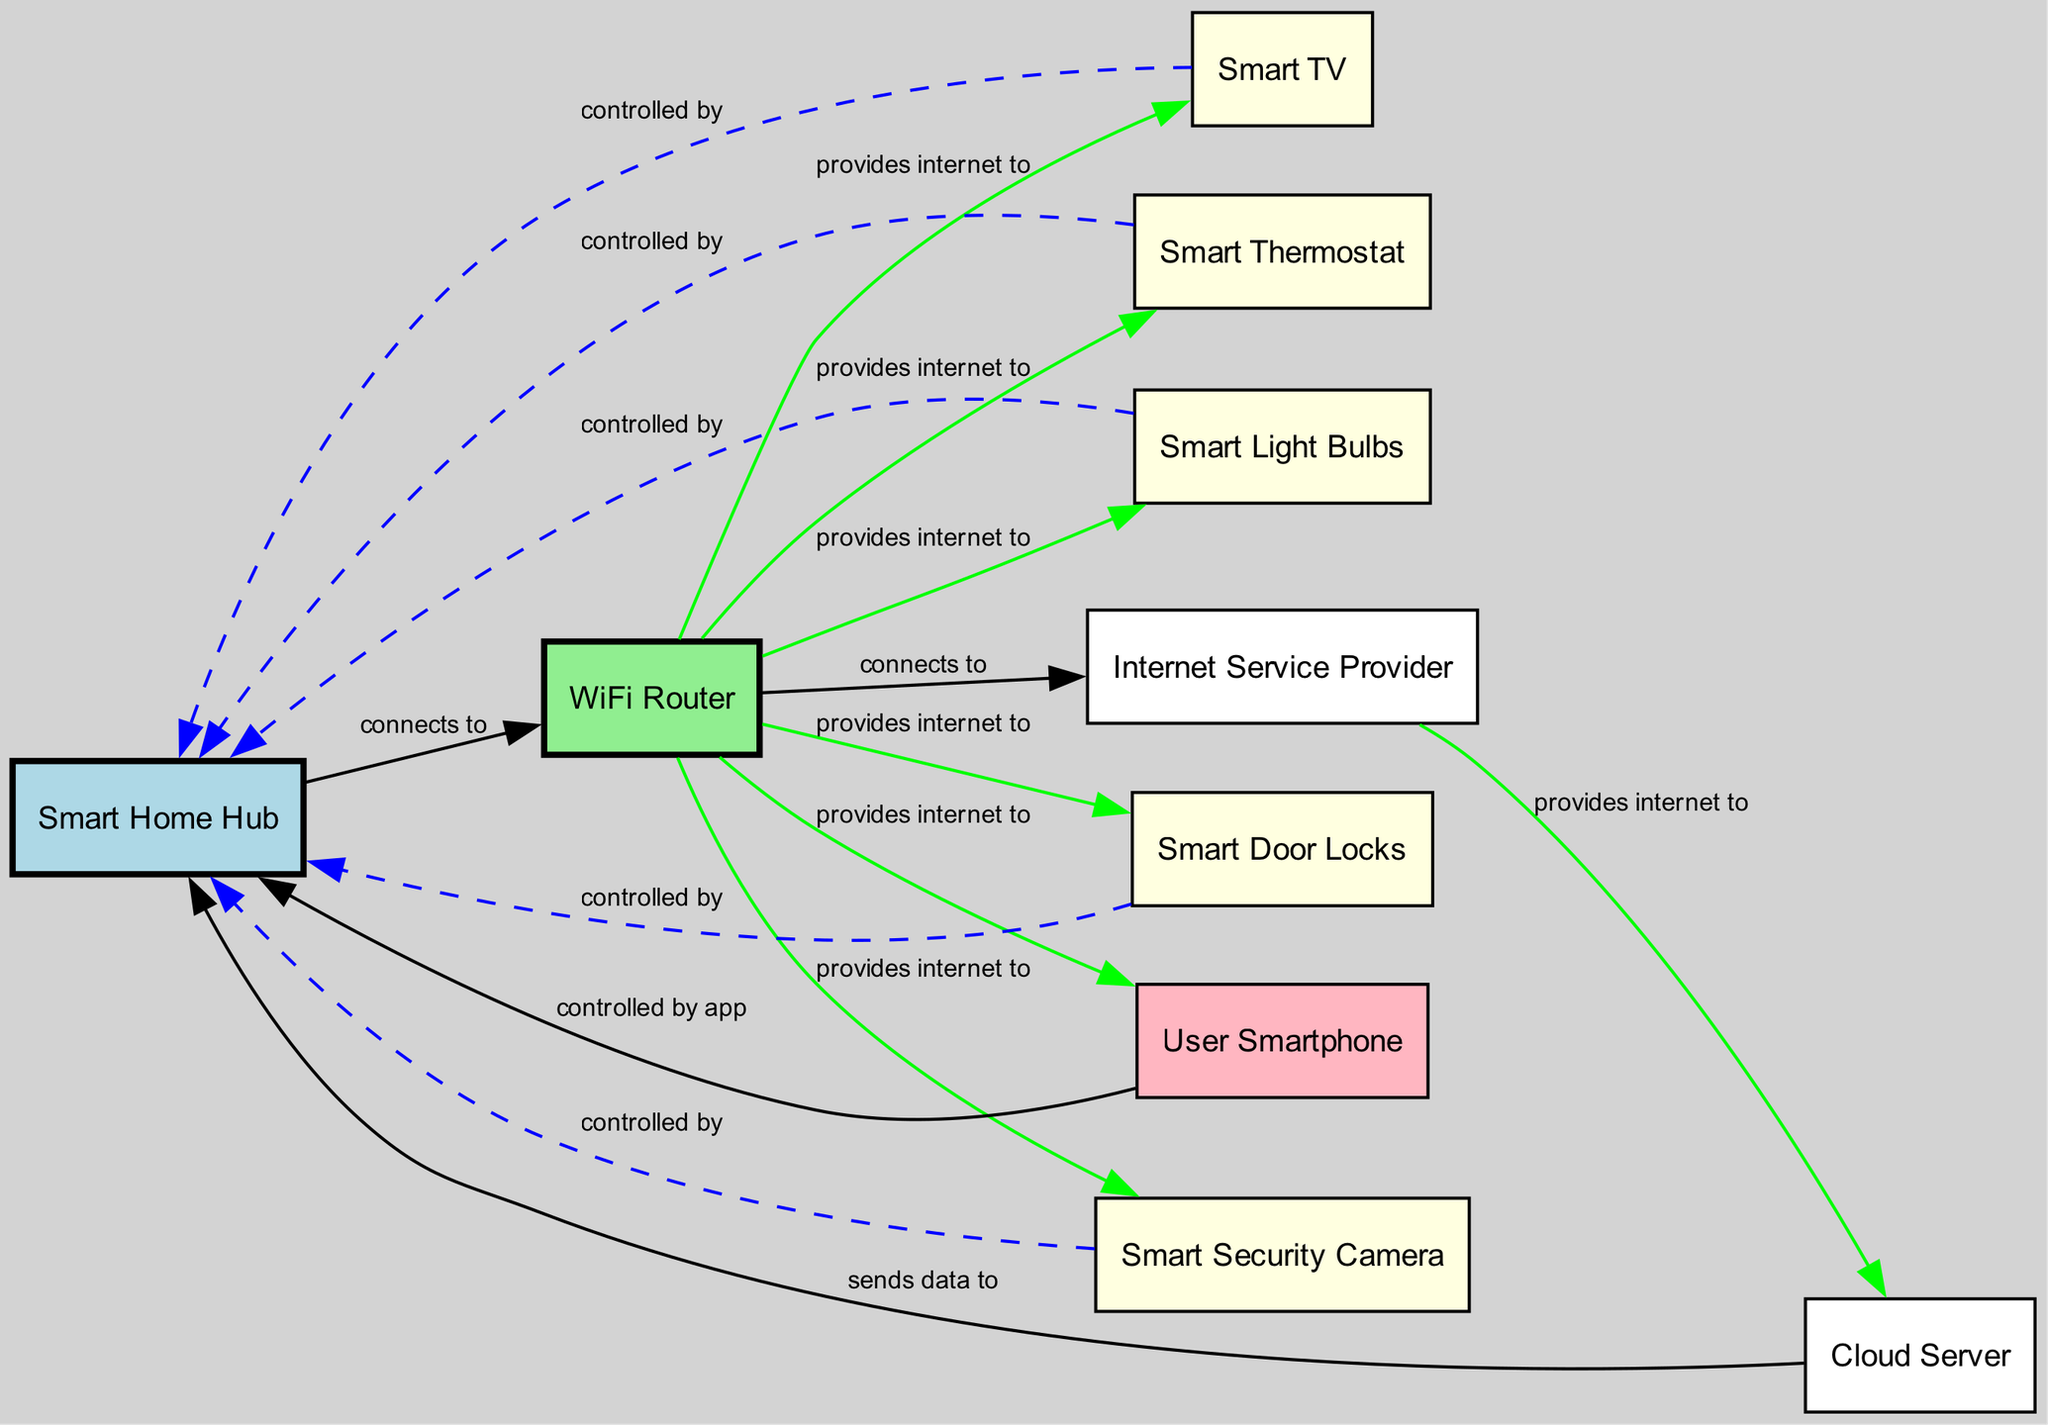How many nodes are there in the diagram? The diagram lists 10 different nodes that represent various components in the smart home environment, including devices like the Smart Home Hub, WiFi Router, and others.
Answer: 10 What is the label of node 3? Node 3 is labeled "Smart Thermostat" as indicated in the data structure for nodes.
Answer: Smart Thermostat Which device connects to the WiFi Router? The edges show that the WiFi Router provides internet to several devices, such as the Smart Thermostat, Smart Light Bulbs, Smart TV, Smart Security Camera, Smart Door Locks, and also connects to the User Smartphone.
Answer: Smart Thermostat, Smart Light Bulbs, Smart TV, Smart Security Camera, Smart Door Locks, User Smartphone How many devices are controlled by the Smart Home Hub? The Smart Home Hub controls five devices: Smart Thermostat, Smart Light Bulbs, Smart TV, Smart Security Camera, and Smart Door Locks.
Answer: 5 What relationship exists between the Cloud Server and Smart Home Hub? The edge described as "sends data to" indicates a direct relationship where the Cloud Server communicates and shares information with the Smart Home Hub.
Answer: sends data to Which device does the User Smartphone control? The diagram shows that the User Smartphone directly controls the Smart Home Hub using an application specified in the relationship defined.
Answer: Smart Home Hub What color represents the WiFi Router in the diagram? The WiFi Router node is designated a light green color according to the specified styles in the diagram's node configuration.
Answer: light green What device is connected to the Internet Service Provider? The diagram shows that the WiFi Router connects to the Internet Service Provider, which is necessary for providing internet connectivity to the smart home environment.
Answer: WiFi Router How many connections does the Smart Home Hub have? The Smart Home Hub has 6 connections, with relationships to the Smart Thermostat, Smart Light Bulbs, Smart TV, Smart Security Camera, Smart Door Locks, and the User Smartphone in the classification of edges.
Answer: 6 